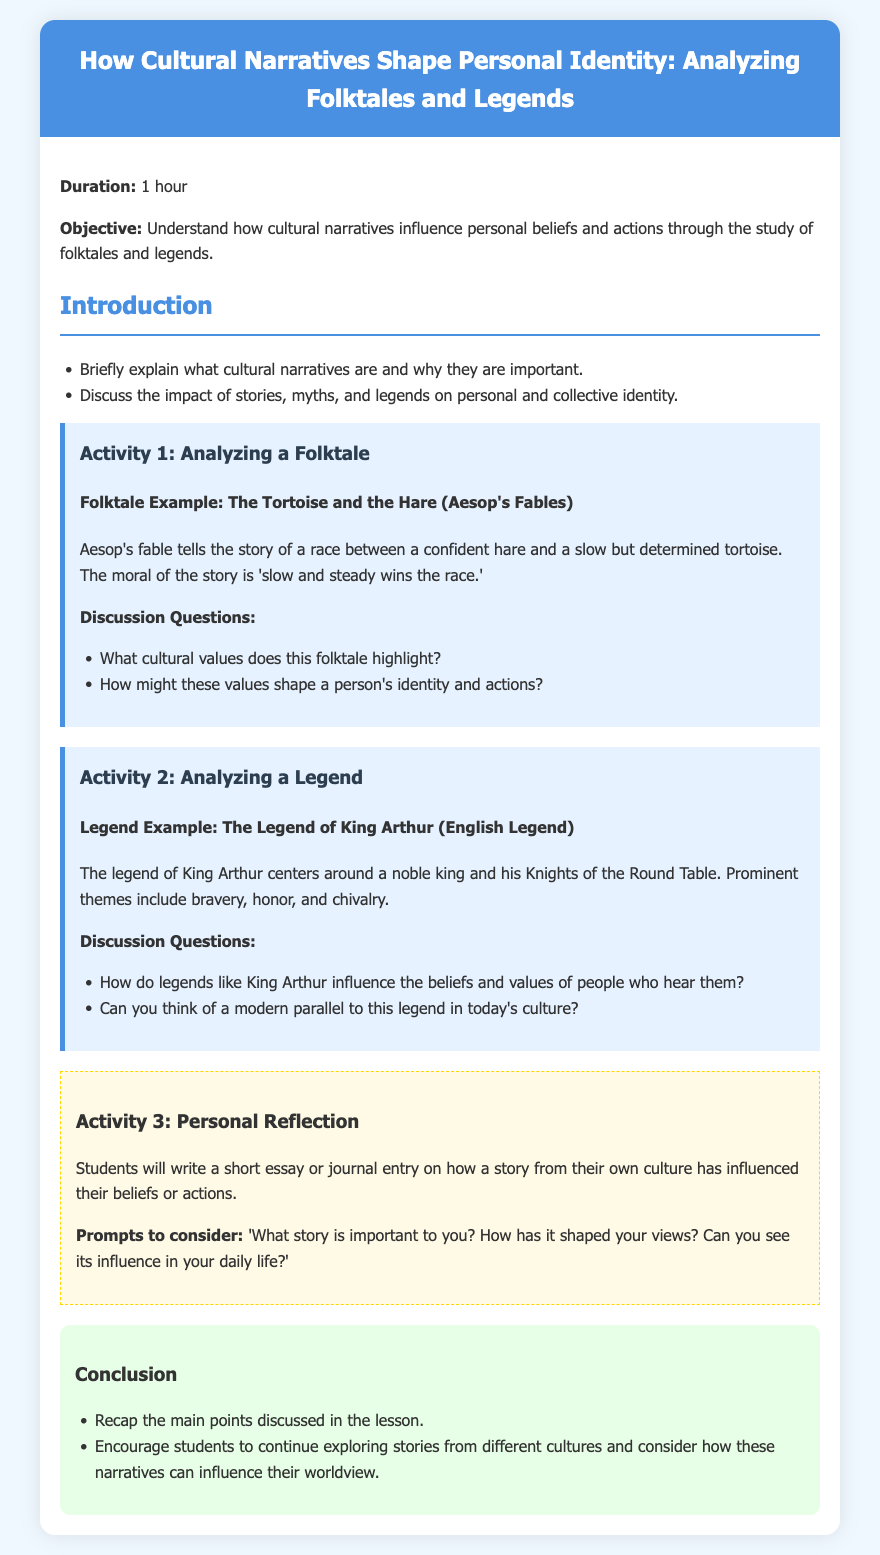what is the duration of the lesson? The duration of the lesson is stated at the beginning of the document as one hour.
Answer: 1 hour what is the objective of the lesson? The objective is to understand how cultural narratives influence personal beliefs and actions through the study of folktales and legends.
Answer: Understand how cultural narratives influence personal beliefs and actions what folktale is analyzed in Activity 1? The document explicitly mentions "The Tortoise and the Hare" as the folktale example for analysis.
Answer: The Tortoise and the Hare what legend is featured in Activity 2? The lesson plan identifies "The Legend of King Arthur" as the legend being discussed in Activity 2.
Answer: The Legend of King Arthur what is one of the discussion questions for Activity 1? The document includes the question, "What cultural values does this folktale highlight?" as a discussion prompt.
Answer: What cultural values does this folktale highlight? what prompts are suggested for the personal reflection activity? The document lists prompts like "What story is important to you? How has it shaped your views?" for personal reflection.
Answer: What story is important to you? How has it shaped your views? how many activities are included in the lesson plan? The lesson plan includes three distinct activities: analyzing a folktale, analyzing a legend, and personal reflection.
Answer: 3 what are students encouraged to do after the lesson? The conclusion suggests that students continue exploring stories from different cultures and consider their influence on their worldview.
Answer: Continue exploring stories from different cultures what color is the background of the document? The background color of the document is specified as a light blue shade (f0f8ff).
Answer: light blue 